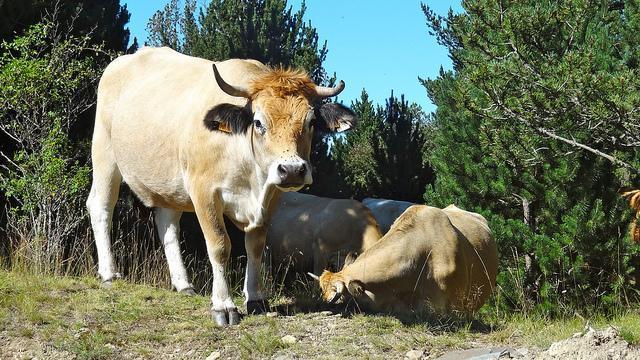How many cows are in the picture?
Give a very brief answer. 3. 